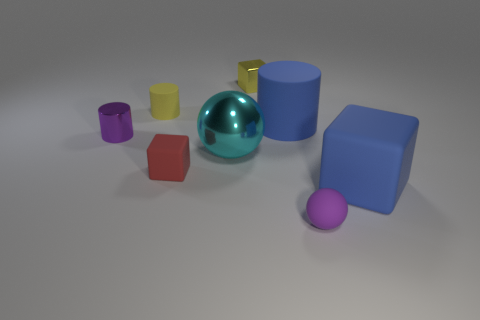Add 1 rubber things. How many objects exist? 9 Subtract all cylinders. How many objects are left? 5 Subtract all cylinders. Subtract all tiny gray metal balls. How many objects are left? 5 Add 3 shiny balls. How many shiny balls are left? 4 Add 2 small red things. How many small red things exist? 3 Subtract 0 cyan blocks. How many objects are left? 8 